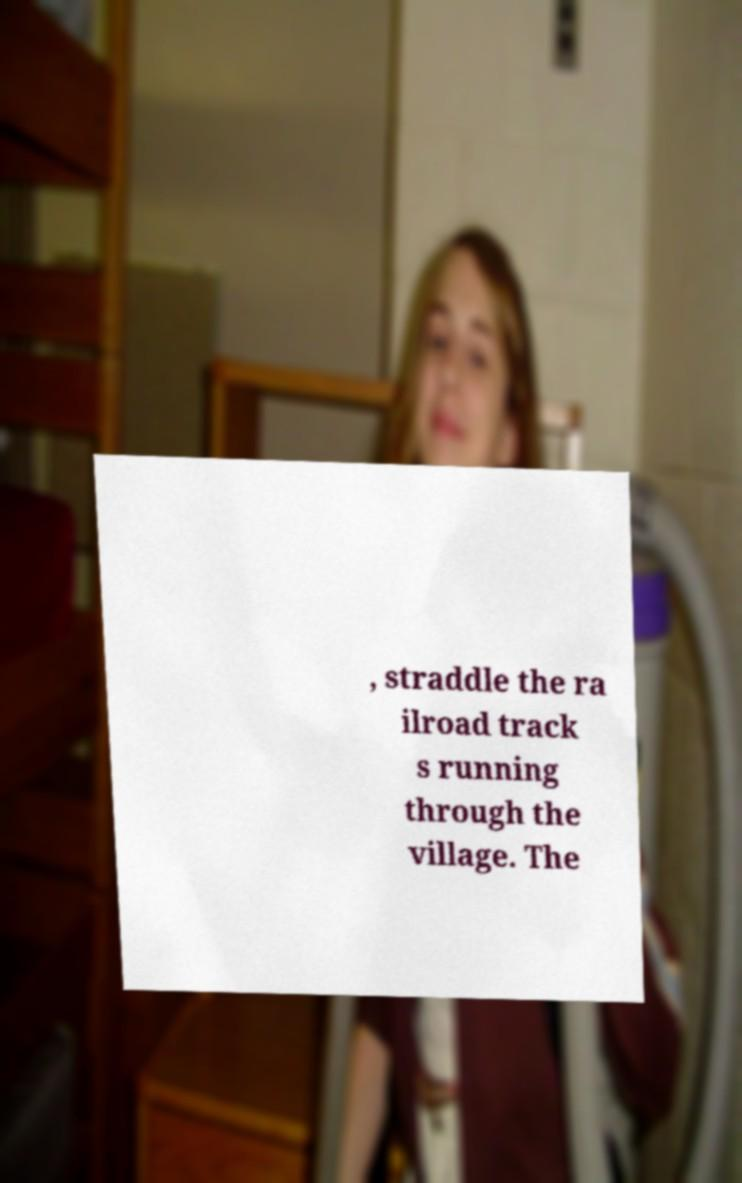I need the written content from this picture converted into text. Can you do that? , straddle the ra ilroad track s running through the village. The 